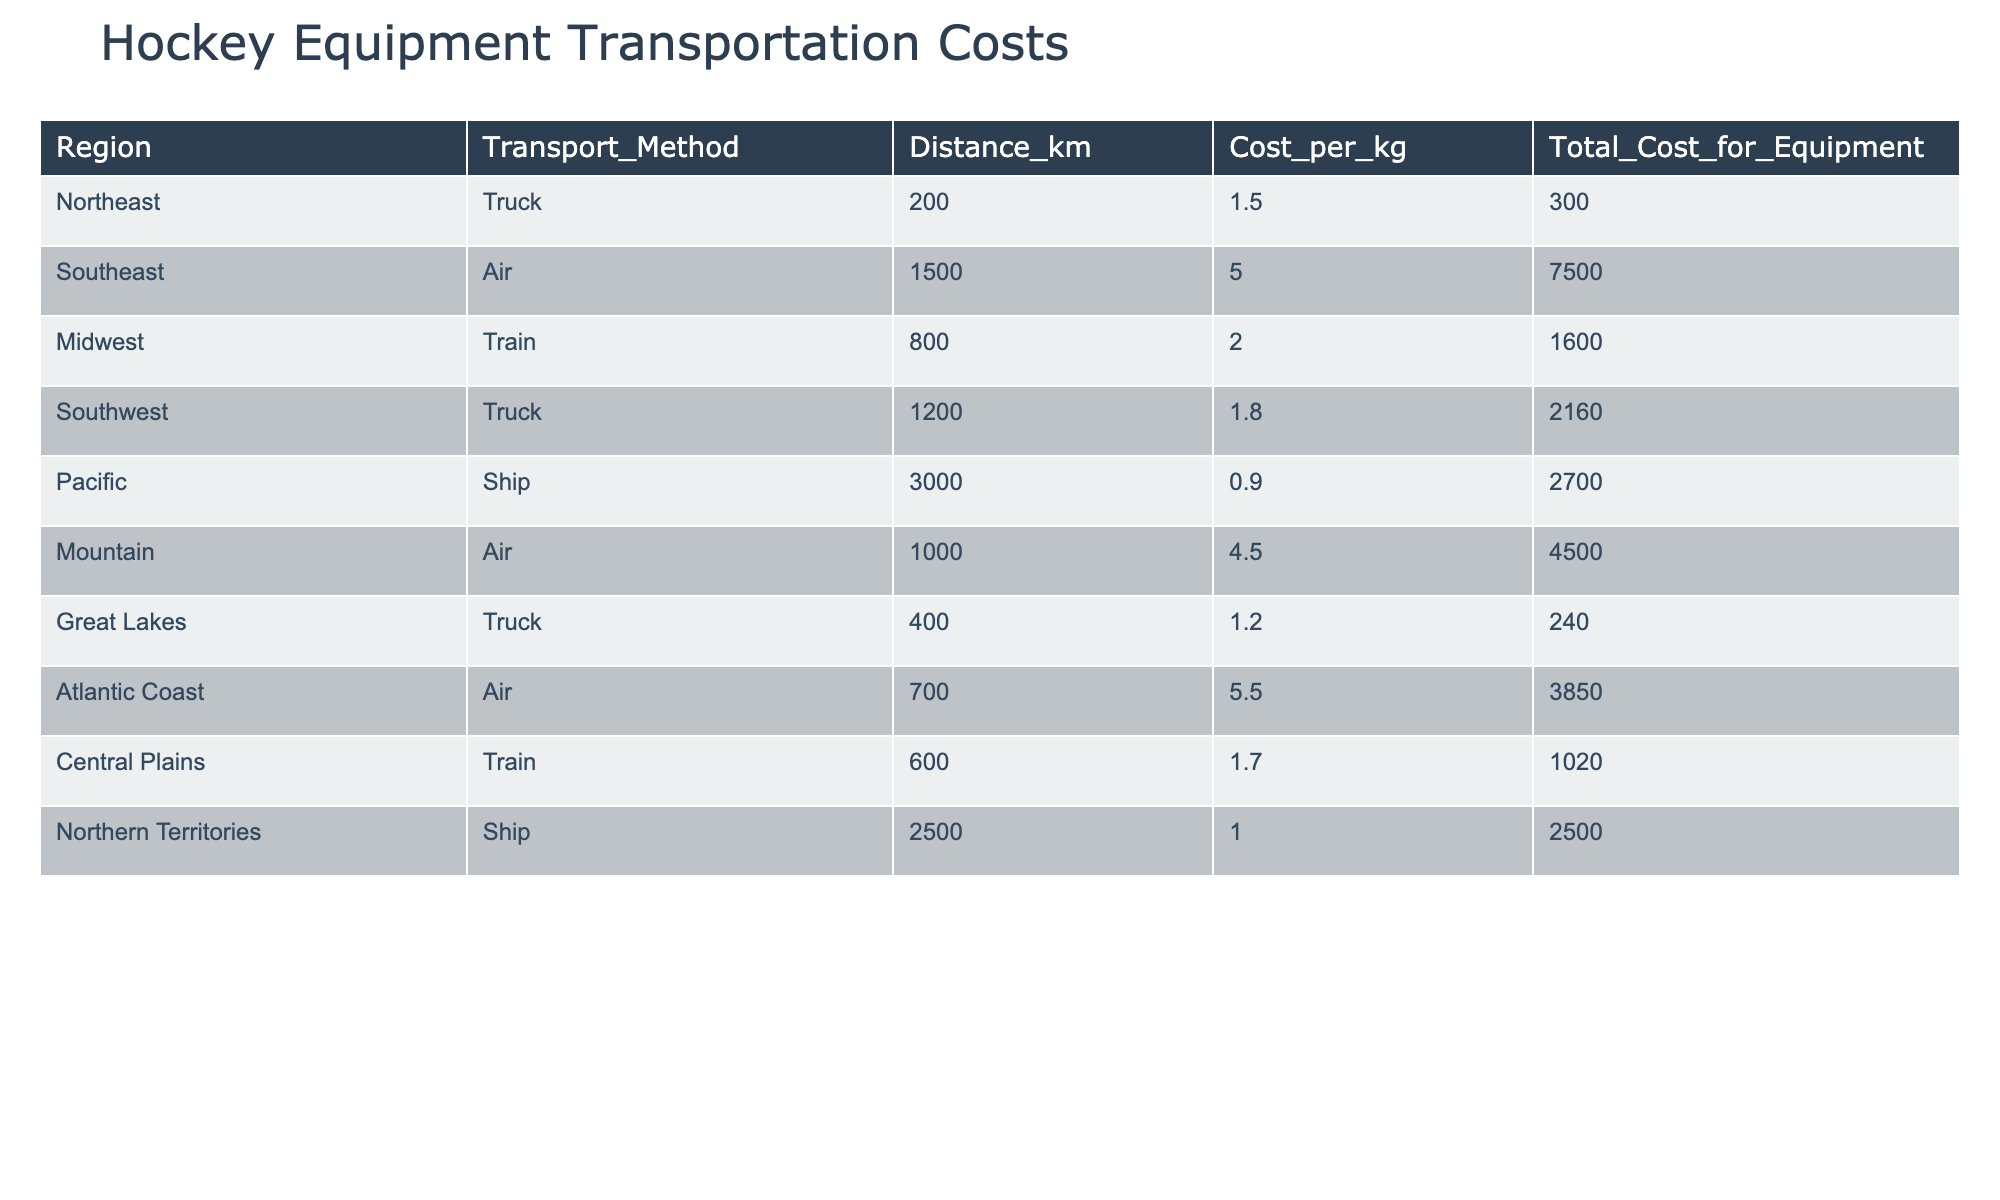What region has the highest transportation cost for delivering hockey equipment? By checking the 'Total Cost for Equipment' column, we see that the Southeast region has a total cost of 7500, which is higher than all other regions.
Answer: Southeast Which transportation method is used for the Pacific region? The table shows that the Pacific region uses Ship as its transportation method.
Answer: Ship What is the total transportation cost for delivering equipment to the Mountain region? The table lists a total cost of 4500 for the Mountain region.
Answer: 4500 What is the average cost per kilogram across all regions? To find the average cost per kilogram, we sum the values in the 'Cost per kg' column: (1.50 + 5.00 + 2.00 + 1.80 + 0.90 + 4.50 + 5.50 + 1.20 + 1.70 + 1.00) = 25.60. There are 10 regions, so the average is 25.60 / 10 = 2.56.
Answer: 2.56 Is the cost of transportation for the Atlantic Coast higher than the cost for the Great Lakes region? The Atlantic Coast has a total cost of 3850, while the Great Lakes region has a cost of 240, which is lower, making the statement true.
Answer: Yes What is the total cost of transportation for equipment in the Truck method across all regions? The Truck method is used in the Northeast, Southwest, and Great Lakes regions with total costs of 300, 2160, and 240, respectively. Adding these together gives 300 + 2160 + 240 = 2700.
Answer: 2700 Which region has the lowest cost per kilogram? By looking at the 'Cost per kg' column, we see that the Pacific region has the lowest value at 0.90 per kilogram.
Answer: Pacific How much more does it cost to send equipment to the Southeast region than to the Central Plains? The Southeast region's total cost is 7500 and the Central Plains is 1020. The difference is 7500 - 1020 = 6480.
Answer: 6480 Is it true that the Northern Territories have a higher transportation cost than the Mountain region? The Northern Territories have a total cost of 2500, while the Mountain region has a total cost of 4500. Since 2500 < 4500, this statement is false.
Answer: No 